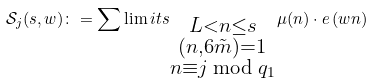<formula> <loc_0><loc_0><loc_500><loc_500>\mathcal { S } _ { j } ( s , w ) \colon = \sum \lim i t s _ { \substack { L < n \leq s \\ ( n , 6 \tilde { m } ) = 1 \\ n \equiv j \bmod { q _ { 1 } } } } \mu ( n ) \cdot e \left ( w n \right )</formula> 